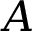<formula> <loc_0><loc_0><loc_500><loc_500>A</formula> 